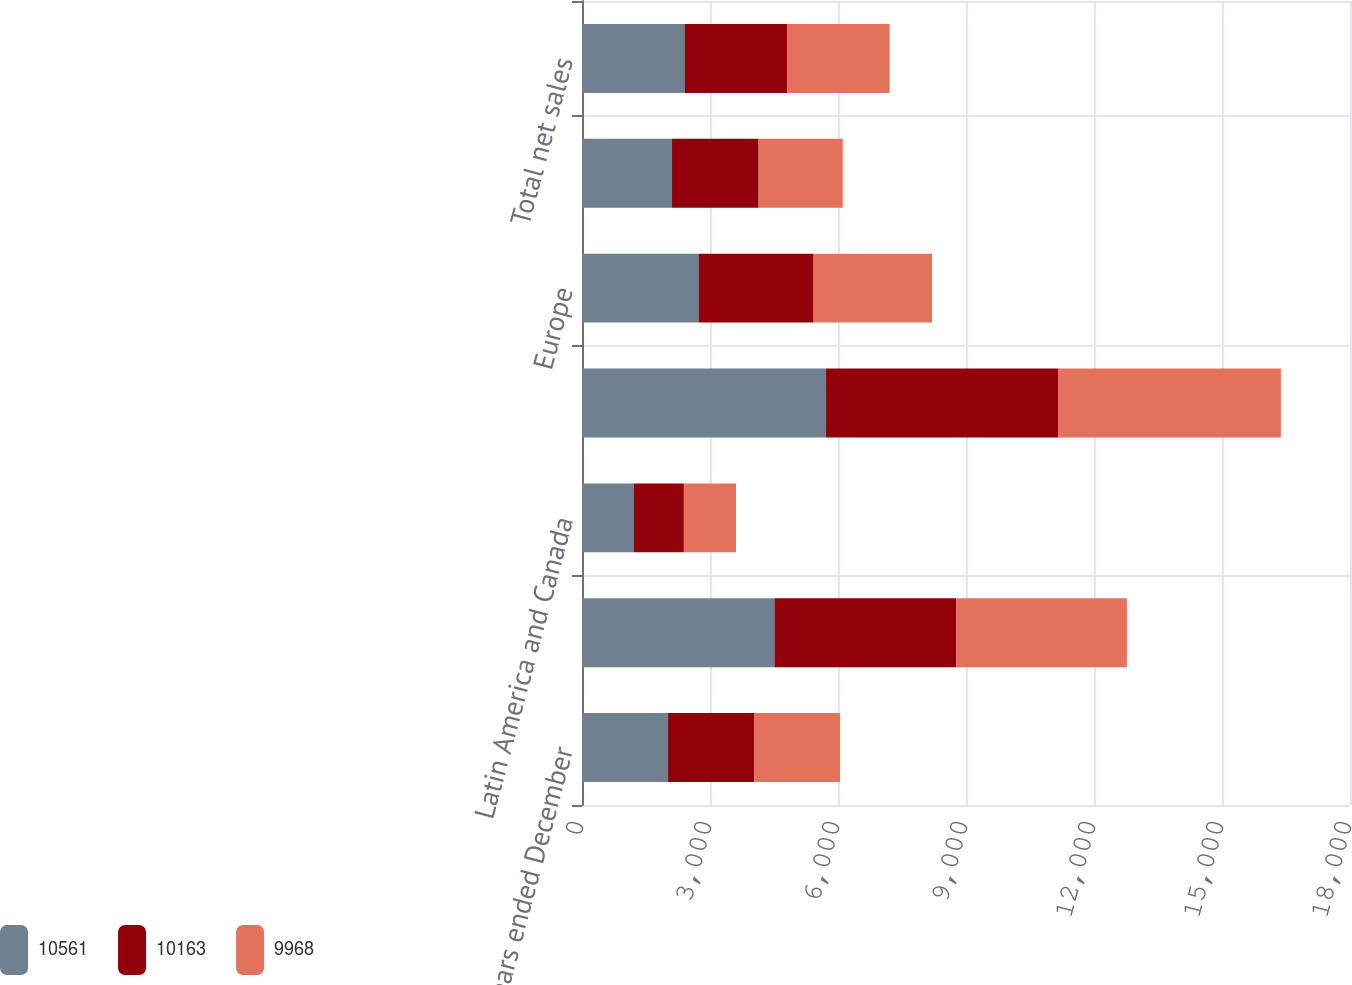Convert chart to OTSL. <chart><loc_0><loc_0><loc_500><loc_500><stacked_bar_chart><ecel><fcel>for the years ended December<fcel>United States<fcel>Latin America and Canada<fcel>Total Americas<fcel>Europe<fcel>Asia-Pacific<fcel>Total net sales<nl><fcel>10561<fcel>2017<fcel>4510<fcel>1210<fcel>5720<fcel>2731<fcel>2110<fcel>2403.5<nl><fcel>10163<fcel>2016<fcel>4259<fcel>1178<fcel>5437<fcel>2697<fcel>2029<fcel>2403.5<nl><fcel>9968<fcel>2015<fcel>4001<fcel>1221<fcel>5222<fcel>2774<fcel>1972<fcel>2403.5<nl></chart> 